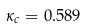<formula> <loc_0><loc_0><loc_500><loc_500>\kappa _ { c } = 0 . 5 8 9</formula> 